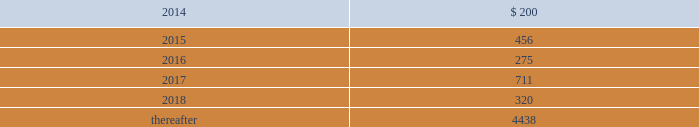The debentures are unsecured , subordinated and junior in right of payment and upon liquidation to all of the company 2019s existing and future senior indebtedness .
In addition , the debentures are effectively subordinated to all of the company 2019s subsidiaries 2019 existing and future indebtedness and other liabilities , including obligations to policyholders .
The debentures do not limit the company 2019s or the company 2019s subsidiaries 2019 ability to incur additional debt , including debt that ranks senior in right of payment and upon liquidation to the debentures .
The debentures rank equally in right of payment and upon liquidation with ( i ) any indebtedness the terms of which provide that such indebtedness ranks equally with the debentures , including guarantees of such indebtedness , ( ii ) the company 2019s existing 8.125% ( 8.125 % ) fixed- to-floating rate junior subordinated debentures due 2068 ( the 201c8.125% ( 201c8.125 % ) debentures 201d ) , ( iii ) the company 2019s income capital obligation notes due 2067 , issuable pursuant to the junior subordinated indenture , dated as of february 12 , 2007 , between the company and wilmington trust company ( the 201cicon securities 201d ) , ( iv ) our trade accounts payable , and ( v ) any of our indebtedness owed to a person who is our subsidiary or employee .
Long-term debt maturities long-term debt maturities ( at par values ) , as of december 31 , 2013 are summarized as follows: .
Shelf registrations on august 9 , 2013 , the company filed with the securities and exchange commission ( the 201csec 201d ) an automatic shelf registration statement ( registration no .
333-190506 ) for the potential offering and sale of debt and equity securities .
The registration statement allows for the following types of securities to be offered : debt securities , junior subordinated debt securities , preferred stock , common stock , depositary shares , warrants , stock purchase contracts , and stock purchase units .
In that the hartford is a well-known seasoned issuer , as defined in rule 405 under the securities act of 1933 , the registration statement went effective immediately upon filing and the hartford may offer and sell an unlimited amount of securities under the registration statement during the three-year life of the registration statement .
Contingent capital facility the company is party to a put option agreement that provides the hartford with the right to require the glen meadow abc trust , a delaware statutory trust , at any time and from time to time , to purchase the hartford 2019s junior subordinated notes in a maximum aggregate principal amount not to exceed $ 500 .
Under the put option agreement , the hartford will pay the glen meadow abc trust premiums on a periodic basis , calculated with respect to the aggregate principal amount of notes that the hartford had the right to put to the glen meadow abc trust for such period .
The hartford has agreed to reimburse the glen meadow abc trust for certain fees and ordinary expenses .
The company holds a variable interest in the glen meadow abc trust where the company is not the primary beneficiary .
As a result , the company did not consolidate the glen meadow abc trust .
As of december 31 , 2013 , the hartford has not exercised its right to require glen meadow abc trust to purchase the notes .
As a result , the notes remain a source of capital for the hfsg holding company .
Revolving credit facilities the company has a senior unsecured revolving credit facility ( the "credit facility" ) that provides for borrowing capacity up to $ 1.75 billion ( which is available in u.s .
Dollars , and in euro , sterling , canadian dollars and japanese yen ) through january 6 , 2016 .
As of december 31 , 2013 , there were no borrowings outstanding under the credit facility .
Of the total availability under the credit facility , up to $ 250 is available to support letters of credit issued on behalf of the company or subsidiaries of the company .
Under the credit facility , the company must maintain a minimum level of consolidated net worth of $ 14.9 billion .
The definition of consolidated net worth under the terms of the credit facility , excludes aoci and includes the company's outstanding junior subordinated debentures and , if any , perpetual preferred securities , net of discount .
In addition , the company 2019s maximum ratio of consolidated total debt to consolidated total capitalization is limited to 35% ( 35 % ) , and the ratio of consolidated total debt of subsidiaries to consolidated total capitalization is limited to 10% ( 10 % ) .
As of december 31 , 2013 , the company was in compliance with all financial covenants under the credit facility .
Table of contents the hartford financial services group , inc .
Notes to consolidated financial statements ( continued ) 13 .
Debt ( continued ) .
As of december 31 , 2013 what was the ratio of the long-term debt maturities due in 2015 compared to 2016? 
Computations: (456 / 275)
Answer: 1.65818. 